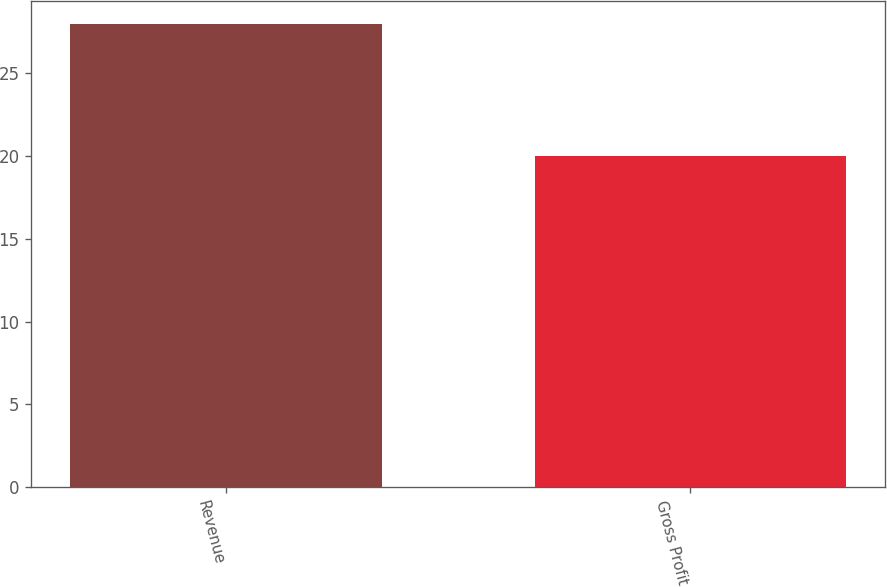Convert chart to OTSL. <chart><loc_0><loc_0><loc_500><loc_500><bar_chart><fcel>Revenue<fcel>Gross Profit<nl><fcel>28<fcel>20<nl></chart> 